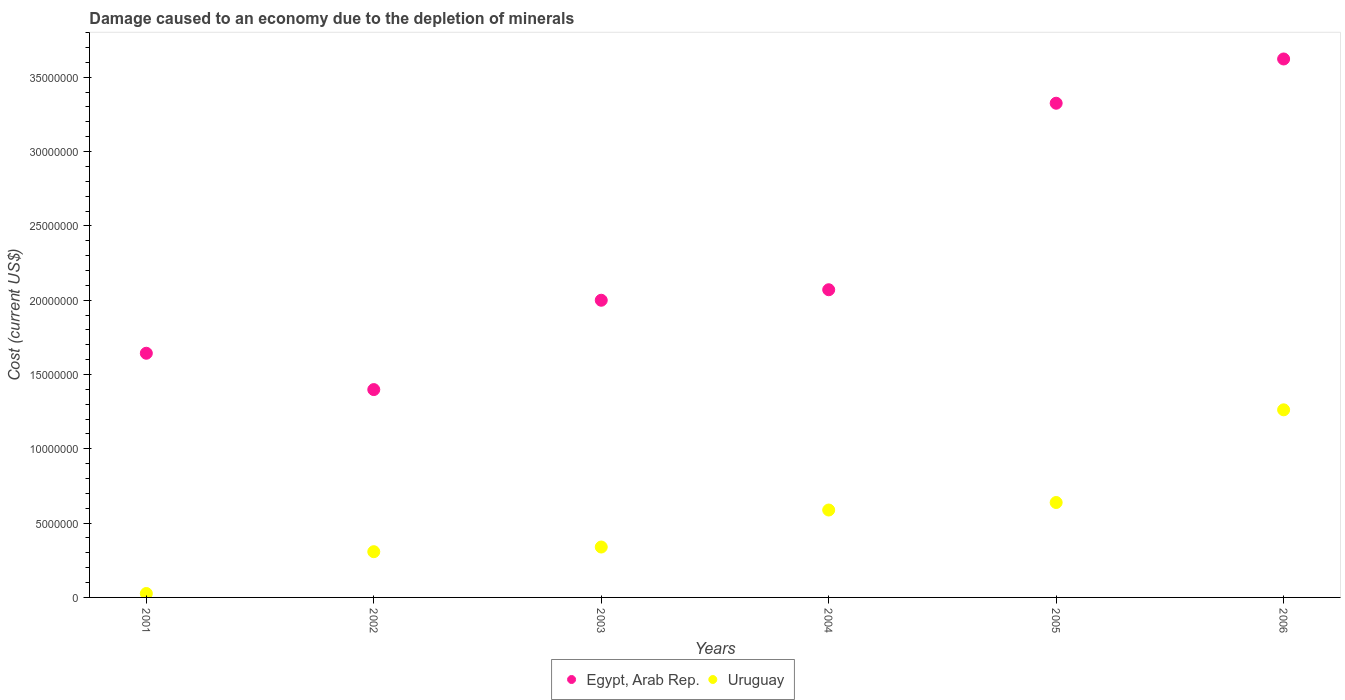How many different coloured dotlines are there?
Provide a short and direct response. 2. Is the number of dotlines equal to the number of legend labels?
Provide a succinct answer. Yes. What is the cost of damage caused due to the depletion of minerals in Egypt, Arab Rep. in 2006?
Make the answer very short. 3.62e+07. Across all years, what is the maximum cost of damage caused due to the depletion of minerals in Uruguay?
Your answer should be compact. 1.26e+07. Across all years, what is the minimum cost of damage caused due to the depletion of minerals in Egypt, Arab Rep.?
Ensure brevity in your answer.  1.40e+07. What is the total cost of damage caused due to the depletion of minerals in Egypt, Arab Rep. in the graph?
Give a very brief answer. 1.41e+08. What is the difference between the cost of damage caused due to the depletion of minerals in Egypt, Arab Rep. in 2001 and that in 2004?
Offer a terse response. -4.27e+06. What is the difference between the cost of damage caused due to the depletion of minerals in Uruguay in 2003 and the cost of damage caused due to the depletion of minerals in Egypt, Arab Rep. in 2001?
Offer a terse response. -1.30e+07. What is the average cost of damage caused due to the depletion of minerals in Egypt, Arab Rep. per year?
Provide a succinct answer. 2.34e+07. In the year 2005, what is the difference between the cost of damage caused due to the depletion of minerals in Uruguay and cost of damage caused due to the depletion of minerals in Egypt, Arab Rep.?
Provide a succinct answer. -2.69e+07. In how many years, is the cost of damage caused due to the depletion of minerals in Uruguay greater than 9000000 US$?
Make the answer very short. 1. What is the ratio of the cost of damage caused due to the depletion of minerals in Egypt, Arab Rep. in 2004 to that in 2006?
Your response must be concise. 0.57. Is the cost of damage caused due to the depletion of minerals in Egypt, Arab Rep. in 2004 less than that in 2006?
Provide a succinct answer. Yes. Is the difference between the cost of damage caused due to the depletion of minerals in Uruguay in 2001 and 2004 greater than the difference between the cost of damage caused due to the depletion of minerals in Egypt, Arab Rep. in 2001 and 2004?
Your response must be concise. No. What is the difference between the highest and the second highest cost of damage caused due to the depletion of minerals in Uruguay?
Keep it short and to the point. 6.24e+06. What is the difference between the highest and the lowest cost of damage caused due to the depletion of minerals in Uruguay?
Offer a terse response. 1.24e+07. In how many years, is the cost of damage caused due to the depletion of minerals in Uruguay greater than the average cost of damage caused due to the depletion of minerals in Uruguay taken over all years?
Keep it short and to the point. 3. Is the sum of the cost of damage caused due to the depletion of minerals in Egypt, Arab Rep. in 2003 and 2004 greater than the maximum cost of damage caused due to the depletion of minerals in Uruguay across all years?
Offer a terse response. Yes. Is the cost of damage caused due to the depletion of minerals in Egypt, Arab Rep. strictly less than the cost of damage caused due to the depletion of minerals in Uruguay over the years?
Your answer should be compact. No. How many dotlines are there?
Ensure brevity in your answer.  2. How many years are there in the graph?
Ensure brevity in your answer.  6. What is the difference between two consecutive major ticks on the Y-axis?
Give a very brief answer. 5.00e+06. Where does the legend appear in the graph?
Your answer should be compact. Bottom center. How many legend labels are there?
Make the answer very short. 2. What is the title of the graph?
Make the answer very short. Damage caused to an economy due to the depletion of minerals. Does "Somalia" appear as one of the legend labels in the graph?
Give a very brief answer. No. What is the label or title of the Y-axis?
Your answer should be very brief. Cost (current US$). What is the Cost (current US$) of Egypt, Arab Rep. in 2001?
Offer a terse response. 1.64e+07. What is the Cost (current US$) of Uruguay in 2001?
Offer a very short reply. 2.64e+05. What is the Cost (current US$) in Egypt, Arab Rep. in 2002?
Give a very brief answer. 1.40e+07. What is the Cost (current US$) in Uruguay in 2002?
Make the answer very short. 3.08e+06. What is the Cost (current US$) of Egypt, Arab Rep. in 2003?
Your answer should be compact. 2.00e+07. What is the Cost (current US$) of Uruguay in 2003?
Give a very brief answer. 3.39e+06. What is the Cost (current US$) in Egypt, Arab Rep. in 2004?
Make the answer very short. 2.07e+07. What is the Cost (current US$) in Uruguay in 2004?
Your answer should be compact. 5.88e+06. What is the Cost (current US$) in Egypt, Arab Rep. in 2005?
Keep it short and to the point. 3.33e+07. What is the Cost (current US$) of Uruguay in 2005?
Provide a succinct answer. 6.39e+06. What is the Cost (current US$) in Egypt, Arab Rep. in 2006?
Give a very brief answer. 3.62e+07. What is the Cost (current US$) in Uruguay in 2006?
Your answer should be compact. 1.26e+07. Across all years, what is the maximum Cost (current US$) in Egypt, Arab Rep.?
Ensure brevity in your answer.  3.62e+07. Across all years, what is the maximum Cost (current US$) in Uruguay?
Give a very brief answer. 1.26e+07. Across all years, what is the minimum Cost (current US$) in Egypt, Arab Rep.?
Offer a very short reply. 1.40e+07. Across all years, what is the minimum Cost (current US$) of Uruguay?
Make the answer very short. 2.64e+05. What is the total Cost (current US$) in Egypt, Arab Rep. in the graph?
Keep it short and to the point. 1.41e+08. What is the total Cost (current US$) in Uruguay in the graph?
Provide a succinct answer. 3.16e+07. What is the difference between the Cost (current US$) of Egypt, Arab Rep. in 2001 and that in 2002?
Give a very brief answer. 2.45e+06. What is the difference between the Cost (current US$) in Uruguay in 2001 and that in 2002?
Give a very brief answer. -2.81e+06. What is the difference between the Cost (current US$) in Egypt, Arab Rep. in 2001 and that in 2003?
Your answer should be compact. -3.57e+06. What is the difference between the Cost (current US$) in Uruguay in 2001 and that in 2003?
Provide a short and direct response. -3.13e+06. What is the difference between the Cost (current US$) in Egypt, Arab Rep. in 2001 and that in 2004?
Make the answer very short. -4.27e+06. What is the difference between the Cost (current US$) of Uruguay in 2001 and that in 2004?
Your answer should be compact. -5.62e+06. What is the difference between the Cost (current US$) of Egypt, Arab Rep. in 2001 and that in 2005?
Give a very brief answer. -1.68e+07. What is the difference between the Cost (current US$) of Uruguay in 2001 and that in 2005?
Give a very brief answer. -6.12e+06. What is the difference between the Cost (current US$) in Egypt, Arab Rep. in 2001 and that in 2006?
Offer a terse response. -1.98e+07. What is the difference between the Cost (current US$) in Uruguay in 2001 and that in 2006?
Provide a succinct answer. -1.24e+07. What is the difference between the Cost (current US$) of Egypt, Arab Rep. in 2002 and that in 2003?
Offer a terse response. -6.01e+06. What is the difference between the Cost (current US$) in Uruguay in 2002 and that in 2003?
Keep it short and to the point. -3.14e+05. What is the difference between the Cost (current US$) of Egypt, Arab Rep. in 2002 and that in 2004?
Ensure brevity in your answer.  -6.72e+06. What is the difference between the Cost (current US$) of Uruguay in 2002 and that in 2004?
Your response must be concise. -2.80e+06. What is the difference between the Cost (current US$) of Egypt, Arab Rep. in 2002 and that in 2005?
Your answer should be compact. -1.93e+07. What is the difference between the Cost (current US$) in Uruguay in 2002 and that in 2005?
Your response must be concise. -3.31e+06. What is the difference between the Cost (current US$) in Egypt, Arab Rep. in 2002 and that in 2006?
Offer a very short reply. -2.22e+07. What is the difference between the Cost (current US$) of Uruguay in 2002 and that in 2006?
Your response must be concise. -9.55e+06. What is the difference between the Cost (current US$) of Egypt, Arab Rep. in 2003 and that in 2004?
Make the answer very short. -7.07e+05. What is the difference between the Cost (current US$) of Uruguay in 2003 and that in 2004?
Offer a terse response. -2.49e+06. What is the difference between the Cost (current US$) in Egypt, Arab Rep. in 2003 and that in 2005?
Your response must be concise. -1.33e+07. What is the difference between the Cost (current US$) in Uruguay in 2003 and that in 2005?
Offer a terse response. -3.00e+06. What is the difference between the Cost (current US$) of Egypt, Arab Rep. in 2003 and that in 2006?
Your answer should be compact. -1.62e+07. What is the difference between the Cost (current US$) in Uruguay in 2003 and that in 2006?
Offer a very short reply. -9.23e+06. What is the difference between the Cost (current US$) in Egypt, Arab Rep. in 2004 and that in 2005?
Keep it short and to the point. -1.25e+07. What is the difference between the Cost (current US$) of Uruguay in 2004 and that in 2005?
Offer a very short reply. -5.05e+05. What is the difference between the Cost (current US$) in Egypt, Arab Rep. in 2004 and that in 2006?
Give a very brief answer. -1.55e+07. What is the difference between the Cost (current US$) of Uruguay in 2004 and that in 2006?
Keep it short and to the point. -6.74e+06. What is the difference between the Cost (current US$) in Egypt, Arab Rep. in 2005 and that in 2006?
Keep it short and to the point. -2.98e+06. What is the difference between the Cost (current US$) of Uruguay in 2005 and that in 2006?
Your answer should be very brief. -6.24e+06. What is the difference between the Cost (current US$) of Egypt, Arab Rep. in 2001 and the Cost (current US$) of Uruguay in 2002?
Keep it short and to the point. 1.34e+07. What is the difference between the Cost (current US$) of Egypt, Arab Rep. in 2001 and the Cost (current US$) of Uruguay in 2003?
Keep it short and to the point. 1.30e+07. What is the difference between the Cost (current US$) in Egypt, Arab Rep. in 2001 and the Cost (current US$) in Uruguay in 2004?
Make the answer very short. 1.05e+07. What is the difference between the Cost (current US$) in Egypt, Arab Rep. in 2001 and the Cost (current US$) in Uruguay in 2005?
Offer a terse response. 1.00e+07. What is the difference between the Cost (current US$) in Egypt, Arab Rep. in 2001 and the Cost (current US$) in Uruguay in 2006?
Give a very brief answer. 3.81e+06. What is the difference between the Cost (current US$) in Egypt, Arab Rep. in 2002 and the Cost (current US$) in Uruguay in 2003?
Provide a succinct answer. 1.06e+07. What is the difference between the Cost (current US$) of Egypt, Arab Rep. in 2002 and the Cost (current US$) of Uruguay in 2004?
Make the answer very short. 8.10e+06. What is the difference between the Cost (current US$) of Egypt, Arab Rep. in 2002 and the Cost (current US$) of Uruguay in 2005?
Make the answer very short. 7.60e+06. What is the difference between the Cost (current US$) in Egypt, Arab Rep. in 2002 and the Cost (current US$) in Uruguay in 2006?
Offer a terse response. 1.36e+06. What is the difference between the Cost (current US$) of Egypt, Arab Rep. in 2003 and the Cost (current US$) of Uruguay in 2004?
Provide a short and direct response. 1.41e+07. What is the difference between the Cost (current US$) of Egypt, Arab Rep. in 2003 and the Cost (current US$) of Uruguay in 2005?
Offer a terse response. 1.36e+07. What is the difference between the Cost (current US$) of Egypt, Arab Rep. in 2003 and the Cost (current US$) of Uruguay in 2006?
Your answer should be very brief. 7.37e+06. What is the difference between the Cost (current US$) of Egypt, Arab Rep. in 2004 and the Cost (current US$) of Uruguay in 2005?
Ensure brevity in your answer.  1.43e+07. What is the difference between the Cost (current US$) of Egypt, Arab Rep. in 2004 and the Cost (current US$) of Uruguay in 2006?
Provide a short and direct response. 8.08e+06. What is the difference between the Cost (current US$) in Egypt, Arab Rep. in 2005 and the Cost (current US$) in Uruguay in 2006?
Provide a short and direct response. 2.06e+07. What is the average Cost (current US$) of Egypt, Arab Rep. per year?
Your answer should be compact. 2.34e+07. What is the average Cost (current US$) of Uruguay per year?
Your answer should be very brief. 5.27e+06. In the year 2001, what is the difference between the Cost (current US$) of Egypt, Arab Rep. and Cost (current US$) of Uruguay?
Provide a short and direct response. 1.62e+07. In the year 2002, what is the difference between the Cost (current US$) in Egypt, Arab Rep. and Cost (current US$) in Uruguay?
Ensure brevity in your answer.  1.09e+07. In the year 2003, what is the difference between the Cost (current US$) of Egypt, Arab Rep. and Cost (current US$) of Uruguay?
Make the answer very short. 1.66e+07. In the year 2004, what is the difference between the Cost (current US$) in Egypt, Arab Rep. and Cost (current US$) in Uruguay?
Give a very brief answer. 1.48e+07. In the year 2005, what is the difference between the Cost (current US$) of Egypt, Arab Rep. and Cost (current US$) of Uruguay?
Offer a very short reply. 2.69e+07. In the year 2006, what is the difference between the Cost (current US$) in Egypt, Arab Rep. and Cost (current US$) in Uruguay?
Make the answer very short. 2.36e+07. What is the ratio of the Cost (current US$) of Egypt, Arab Rep. in 2001 to that in 2002?
Make the answer very short. 1.17. What is the ratio of the Cost (current US$) of Uruguay in 2001 to that in 2002?
Offer a terse response. 0.09. What is the ratio of the Cost (current US$) of Egypt, Arab Rep. in 2001 to that in 2003?
Your answer should be very brief. 0.82. What is the ratio of the Cost (current US$) in Uruguay in 2001 to that in 2003?
Your answer should be compact. 0.08. What is the ratio of the Cost (current US$) of Egypt, Arab Rep. in 2001 to that in 2004?
Ensure brevity in your answer.  0.79. What is the ratio of the Cost (current US$) in Uruguay in 2001 to that in 2004?
Provide a succinct answer. 0.04. What is the ratio of the Cost (current US$) of Egypt, Arab Rep. in 2001 to that in 2005?
Keep it short and to the point. 0.49. What is the ratio of the Cost (current US$) in Uruguay in 2001 to that in 2005?
Offer a very short reply. 0.04. What is the ratio of the Cost (current US$) of Egypt, Arab Rep. in 2001 to that in 2006?
Your response must be concise. 0.45. What is the ratio of the Cost (current US$) of Uruguay in 2001 to that in 2006?
Keep it short and to the point. 0.02. What is the ratio of the Cost (current US$) of Egypt, Arab Rep. in 2002 to that in 2003?
Keep it short and to the point. 0.7. What is the ratio of the Cost (current US$) of Uruguay in 2002 to that in 2003?
Offer a very short reply. 0.91. What is the ratio of the Cost (current US$) in Egypt, Arab Rep. in 2002 to that in 2004?
Your answer should be very brief. 0.68. What is the ratio of the Cost (current US$) in Uruguay in 2002 to that in 2004?
Offer a very short reply. 0.52. What is the ratio of the Cost (current US$) of Egypt, Arab Rep. in 2002 to that in 2005?
Provide a succinct answer. 0.42. What is the ratio of the Cost (current US$) in Uruguay in 2002 to that in 2005?
Your answer should be very brief. 0.48. What is the ratio of the Cost (current US$) of Egypt, Arab Rep. in 2002 to that in 2006?
Provide a succinct answer. 0.39. What is the ratio of the Cost (current US$) in Uruguay in 2002 to that in 2006?
Provide a short and direct response. 0.24. What is the ratio of the Cost (current US$) in Egypt, Arab Rep. in 2003 to that in 2004?
Make the answer very short. 0.97. What is the ratio of the Cost (current US$) in Uruguay in 2003 to that in 2004?
Provide a short and direct response. 0.58. What is the ratio of the Cost (current US$) in Egypt, Arab Rep. in 2003 to that in 2005?
Your response must be concise. 0.6. What is the ratio of the Cost (current US$) in Uruguay in 2003 to that in 2005?
Provide a short and direct response. 0.53. What is the ratio of the Cost (current US$) of Egypt, Arab Rep. in 2003 to that in 2006?
Provide a short and direct response. 0.55. What is the ratio of the Cost (current US$) in Uruguay in 2003 to that in 2006?
Ensure brevity in your answer.  0.27. What is the ratio of the Cost (current US$) in Egypt, Arab Rep. in 2004 to that in 2005?
Keep it short and to the point. 0.62. What is the ratio of the Cost (current US$) of Uruguay in 2004 to that in 2005?
Keep it short and to the point. 0.92. What is the ratio of the Cost (current US$) of Egypt, Arab Rep. in 2004 to that in 2006?
Your response must be concise. 0.57. What is the ratio of the Cost (current US$) in Uruguay in 2004 to that in 2006?
Keep it short and to the point. 0.47. What is the ratio of the Cost (current US$) of Egypt, Arab Rep. in 2005 to that in 2006?
Your response must be concise. 0.92. What is the ratio of the Cost (current US$) of Uruguay in 2005 to that in 2006?
Your response must be concise. 0.51. What is the difference between the highest and the second highest Cost (current US$) in Egypt, Arab Rep.?
Ensure brevity in your answer.  2.98e+06. What is the difference between the highest and the second highest Cost (current US$) of Uruguay?
Provide a succinct answer. 6.24e+06. What is the difference between the highest and the lowest Cost (current US$) in Egypt, Arab Rep.?
Ensure brevity in your answer.  2.22e+07. What is the difference between the highest and the lowest Cost (current US$) in Uruguay?
Give a very brief answer. 1.24e+07. 